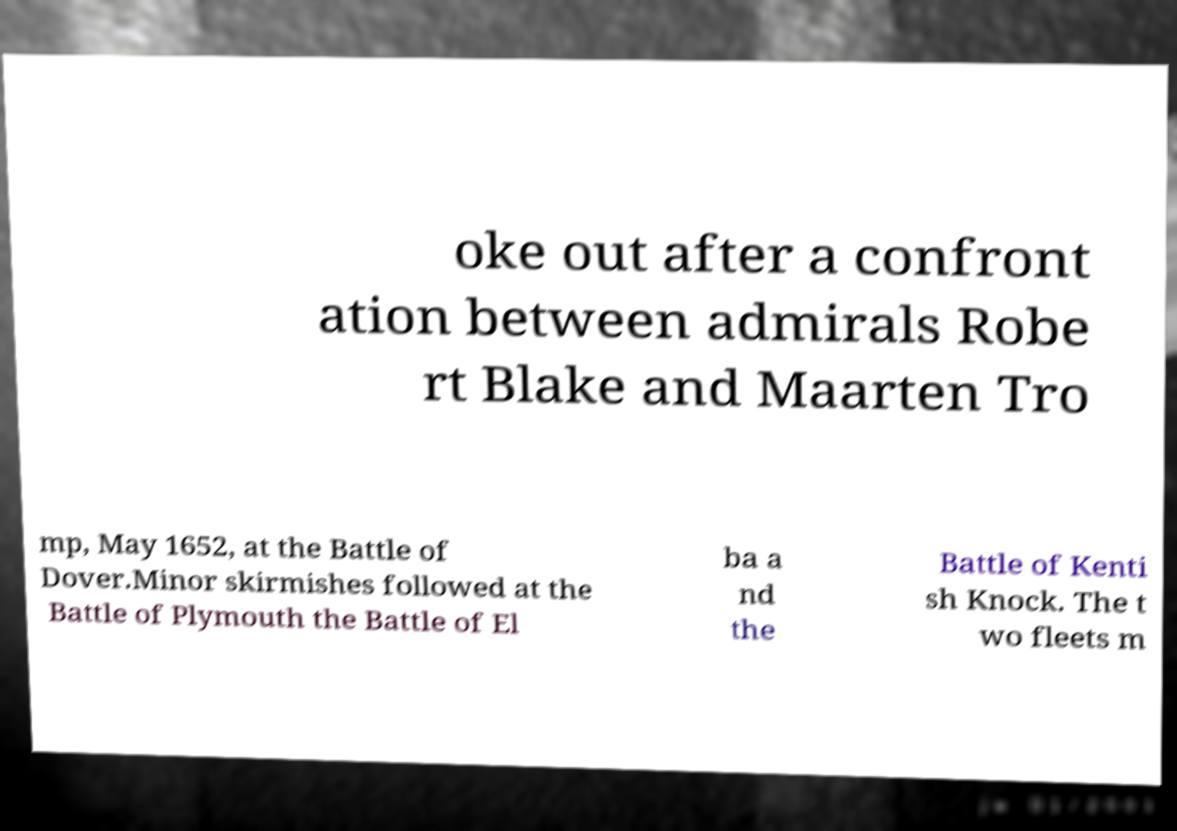What messages or text are displayed in this image? I need them in a readable, typed format. oke out after a confront ation between admirals Robe rt Blake and Maarten Tro mp, May 1652, at the Battle of Dover.Minor skirmishes followed at the Battle of Plymouth the Battle of El ba a nd the Battle of Kenti sh Knock. The t wo fleets m 